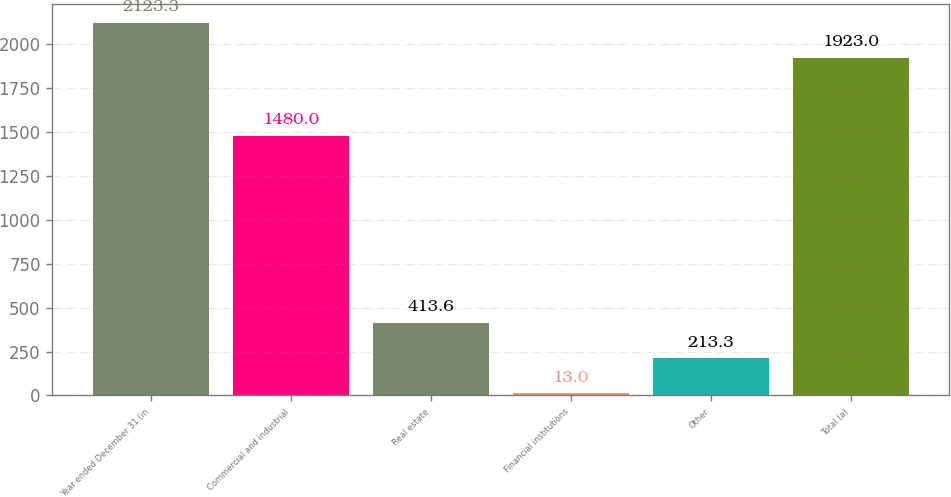Convert chart to OTSL. <chart><loc_0><loc_0><loc_500><loc_500><bar_chart><fcel>Year ended December 31 (in<fcel>Commercial and industrial<fcel>Real estate<fcel>Financial institutions<fcel>Other<fcel>Total (a)<nl><fcel>2123.3<fcel>1480<fcel>413.6<fcel>13<fcel>213.3<fcel>1923<nl></chart> 